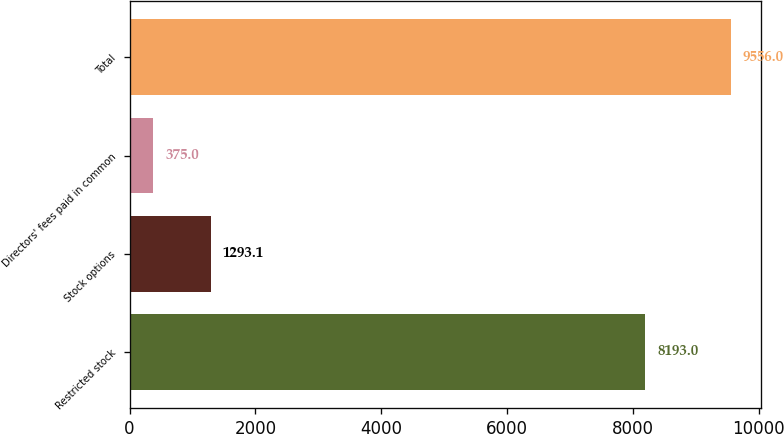Convert chart. <chart><loc_0><loc_0><loc_500><loc_500><bar_chart><fcel>Restricted stock<fcel>Stock options<fcel>Directors' fees paid in common<fcel>Total<nl><fcel>8193<fcel>1293.1<fcel>375<fcel>9556<nl></chart> 